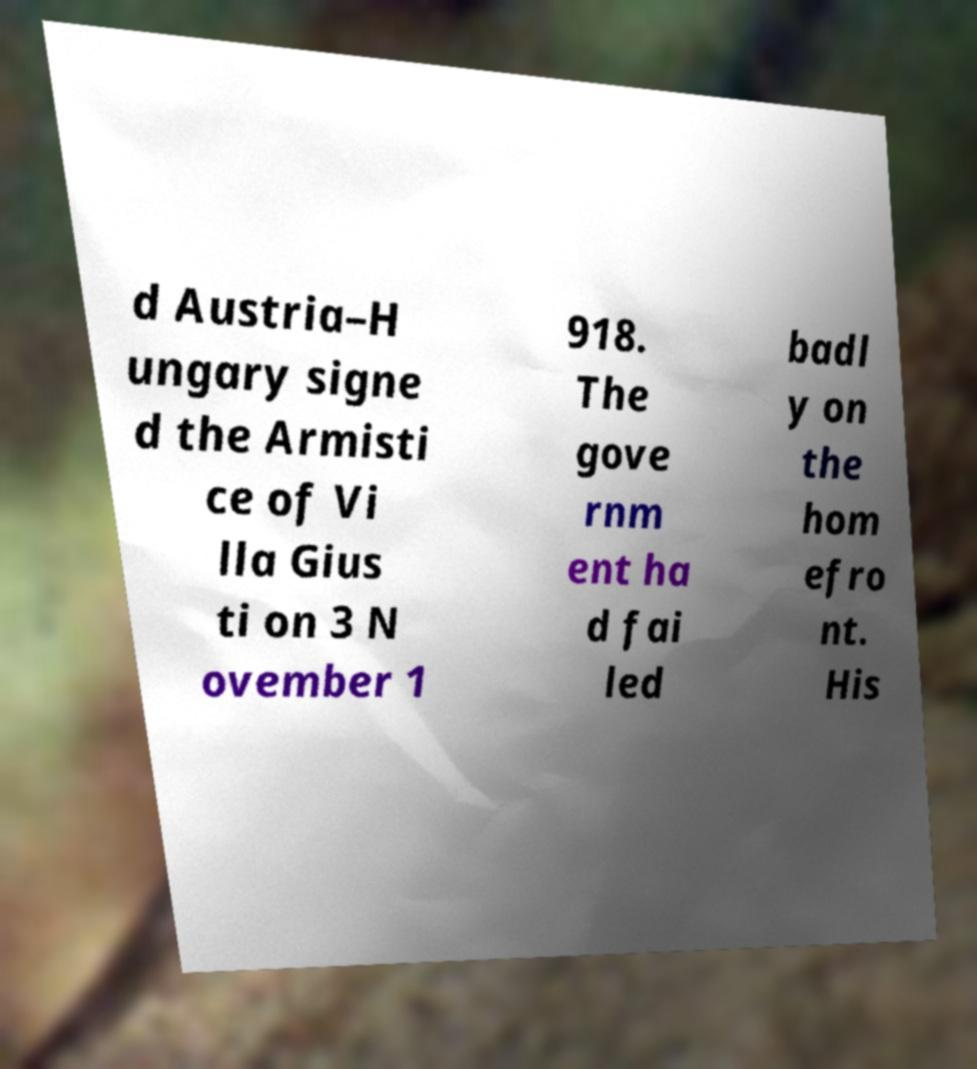Can you read and provide the text displayed in the image?This photo seems to have some interesting text. Can you extract and type it out for me? d Austria–H ungary signe d the Armisti ce of Vi lla Gius ti on 3 N ovember 1 918. The gove rnm ent ha d fai led badl y on the hom efro nt. His 